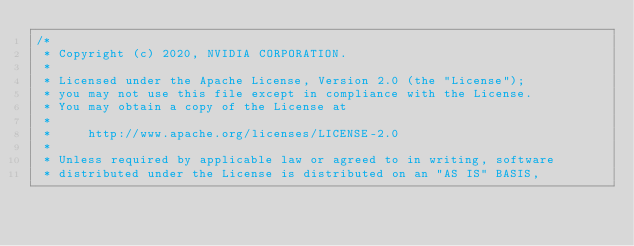Convert code to text. <code><loc_0><loc_0><loc_500><loc_500><_Cuda_>/*
 * Copyright (c) 2020, NVIDIA CORPORATION.
 *
 * Licensed under the Apache License, Version 2.0 (the "License");
 * you may not use this file except in compliance with the License.
 * You may obtain a copy of the License at
 *
 *     http://www.apache.org/licenses/LICENSE-2.0
 *
 * Unless required by applicable law or agreed to in writing, software
 * distributed under the License is distributed on an "AS IS" BASIS,</code> 